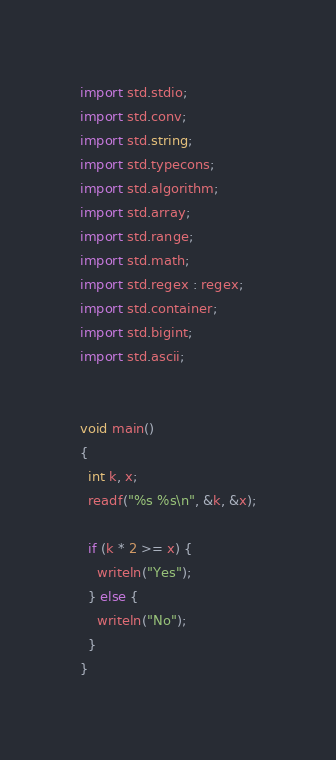<code> <loc_0><loc_0><loc_500><loc_500><_D_>import std.stdio;
import std.conv;
import std.string;
import std.typecons;
import std.algorithm;
import std.array;
import std.range;
import std.math;
import std.regex : regex;
import std.container;
import std.bigint;
import std.ascii;


void main()
{
  int k, x;
  readf("%s %s\n", &k, &x);

  if (k * 2 >= x) {
    writeln("Yes");
  } else {
    writeln("No");
  }
}
</code> 